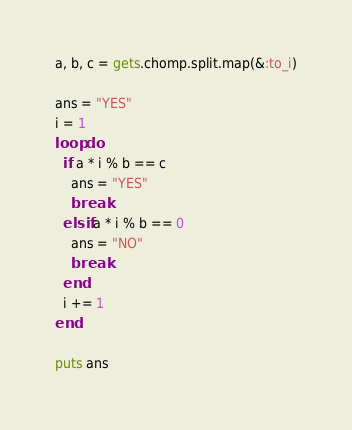Convert code to text. <code><loc_0><loc_0><loc_500><loc_500><_Ruby_>a, b, c = gets.chomp.split.map(&:to_i)

ans = "YES"
i = 1
loop do
  if a * i % b == c
    ans = "YES"
    break
  elsif a * i % b == 0
    ans = "NO"
    break
  end
  i += 1
end

puts ans</code> 